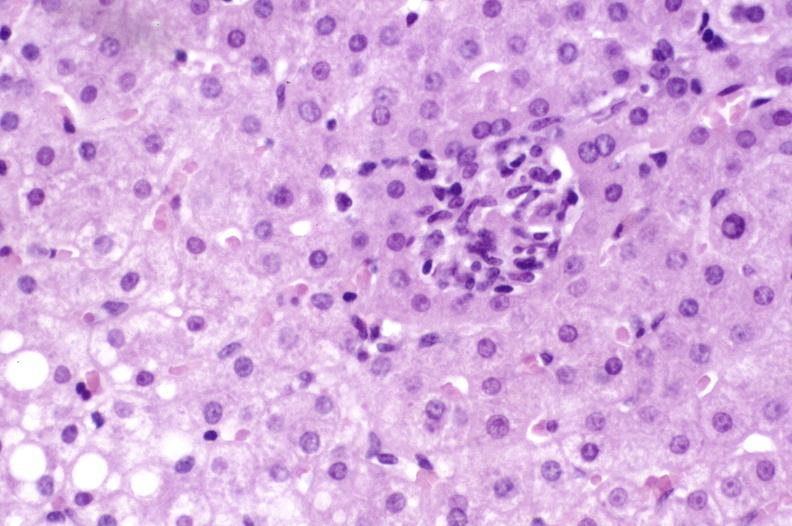what does this image show?
Answer the question using a single word or phrase. Primary biliary cirrhosis 